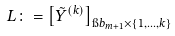Convert formula to latex. <formula><loc_0><loc_0><loc_500><loc_500>L \colon = \left [ \tilde { Y } ^ { ( k ) } \right ] _ { \i b _ { m + 1 } \times \{ 1 , \dots , k \} }</formula> 